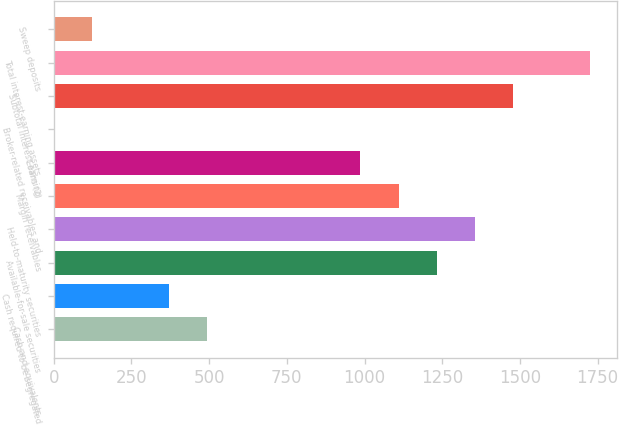Convert chart to OTSL. <chart><loc_0><loc_0><loc_500><loc_500><bar_chart><fcel>Cash and equivalents<fcel>Cash required to be segregated<fcel>Available-for-sale securities<fcel>Held-to-maturity securities<fcel>Margin receivables<fcel>Loans (2)<fcel>Broker-related receivables and<fcel>Subtotal interest-earning<fcel>Total interest-earning assets<fcel>Sweep deposits<nl><fcel>493.8<fcel>370.6<fcel>1233<fcel>1356.2<fcel>1109.8<fcel>986.6<fcel>1<fcel>1479.4<fcel>1725.8<fcel>124.2<nl></chart> 